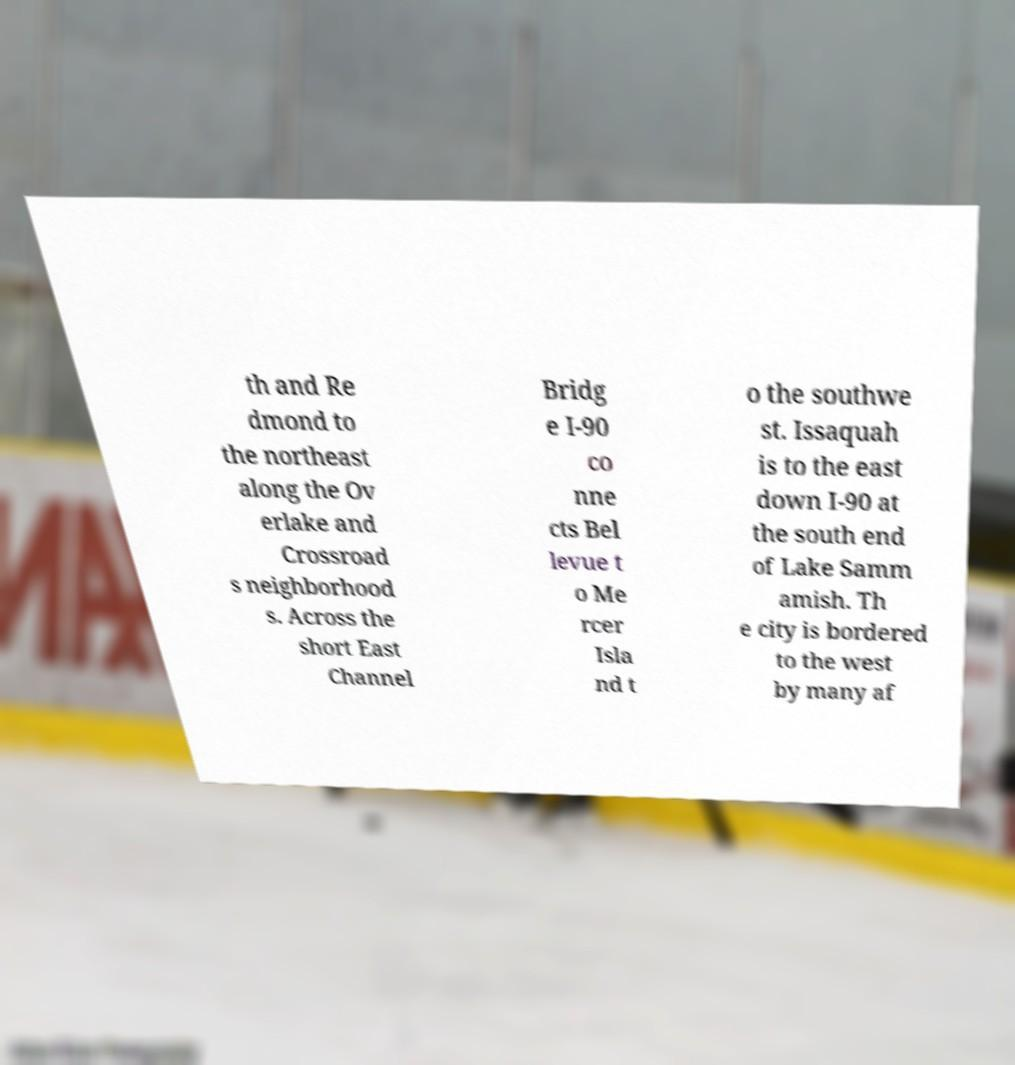What messages or text are displayed in this image? I need them in a readable, typed format. th and Re dmond to the northeast along the Ov erlake and Crossroad s neighborhood s. Across the short East Channel Bridg e I-90 co nne cts Bel levue t o Me rcer Isla nd t o the southwe st. Issaquah is to the east down I-90 at the south end of Lake Samm amish. Th e city is bordered to the west by many af 